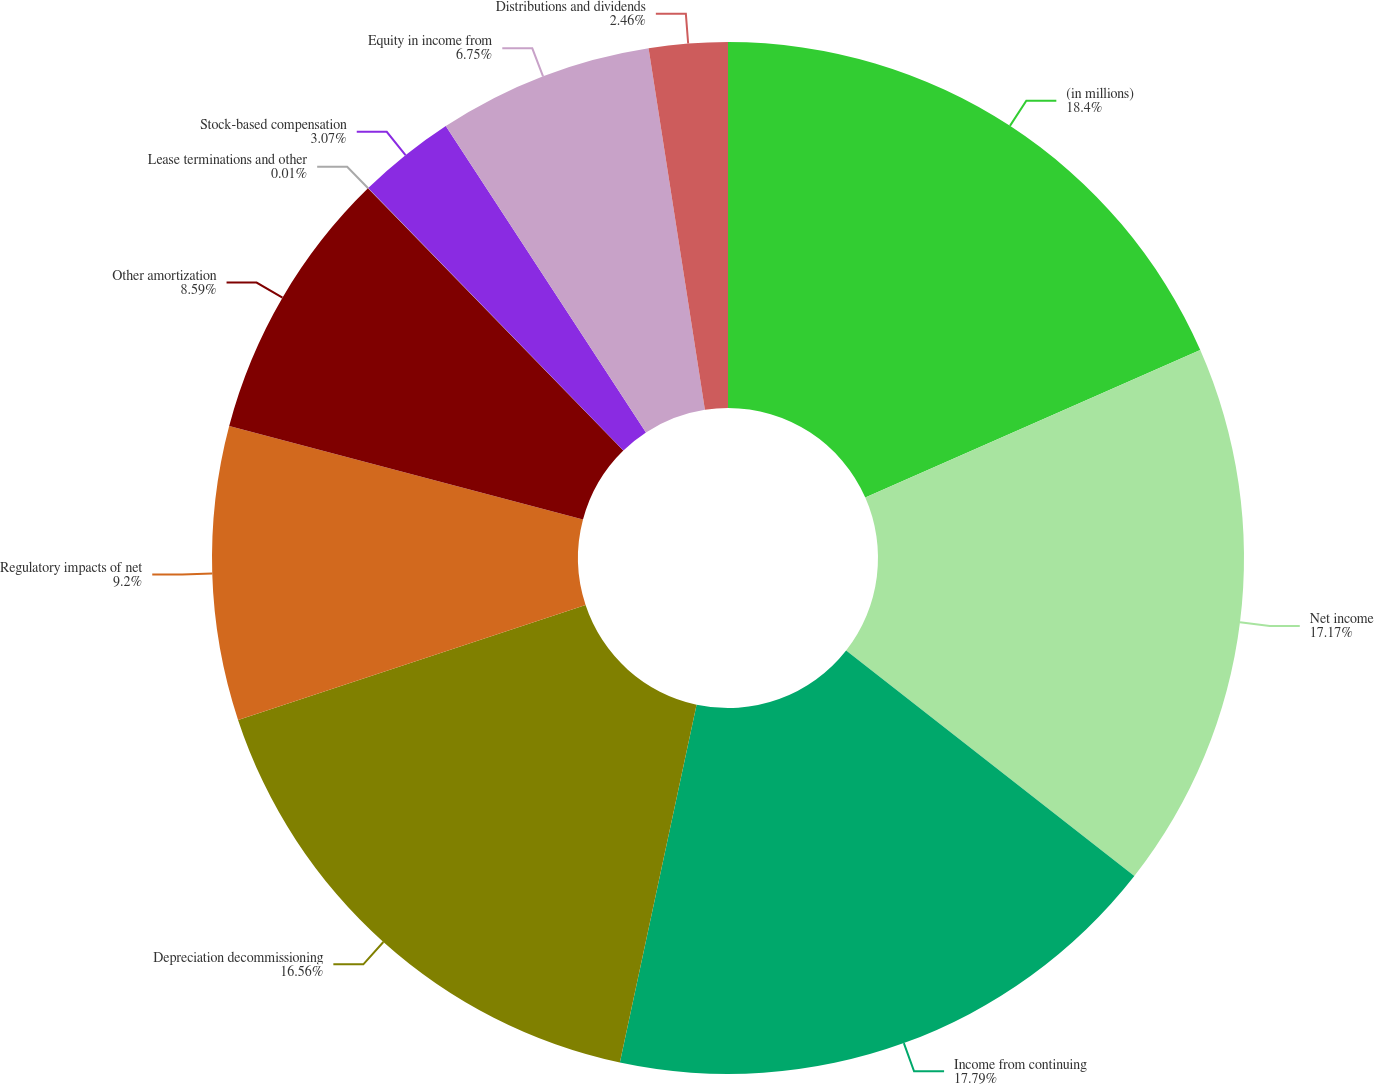<chart> <loc_0><loc_0><loc_500><loc_500><pie_chart><fcel>(in millions)<fcel>Net income<fcel>Income from continuing<fcel>Depreciation decommissioning<fcel>Regulatory impacts of net<fcel>Other amortization<fcel>Lease terminations and other<fcel>Stock-based compensation<fcel>Equity in income from<fcel>Distributions and dividends<nl><fcel>18.4%<fcel>17.17%<fcel>17.79%<fcel>16.56%<fcel>9.2%<fcel>8.59%<fcel>0.01%<fcel>3.07%<fcel>6.75%<fcel>2.46%<nl></chart> 